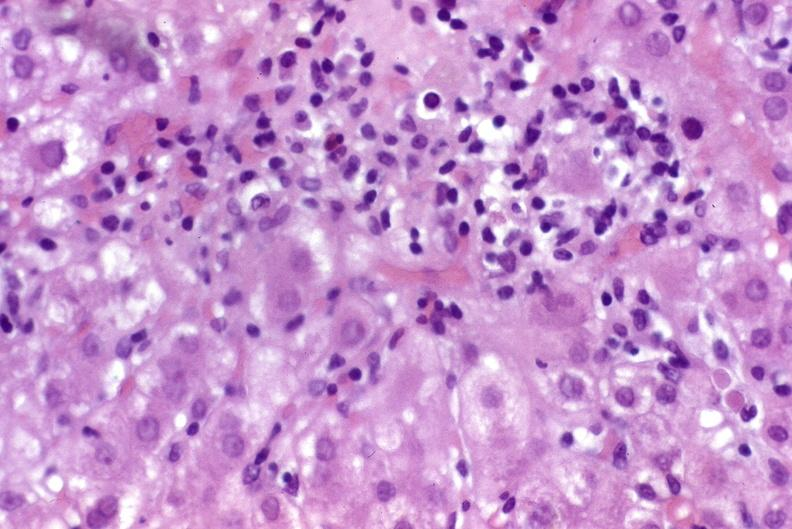does this image show recurrent hepatitis c virus?
Answer the question using a single word or phrase. Yes 